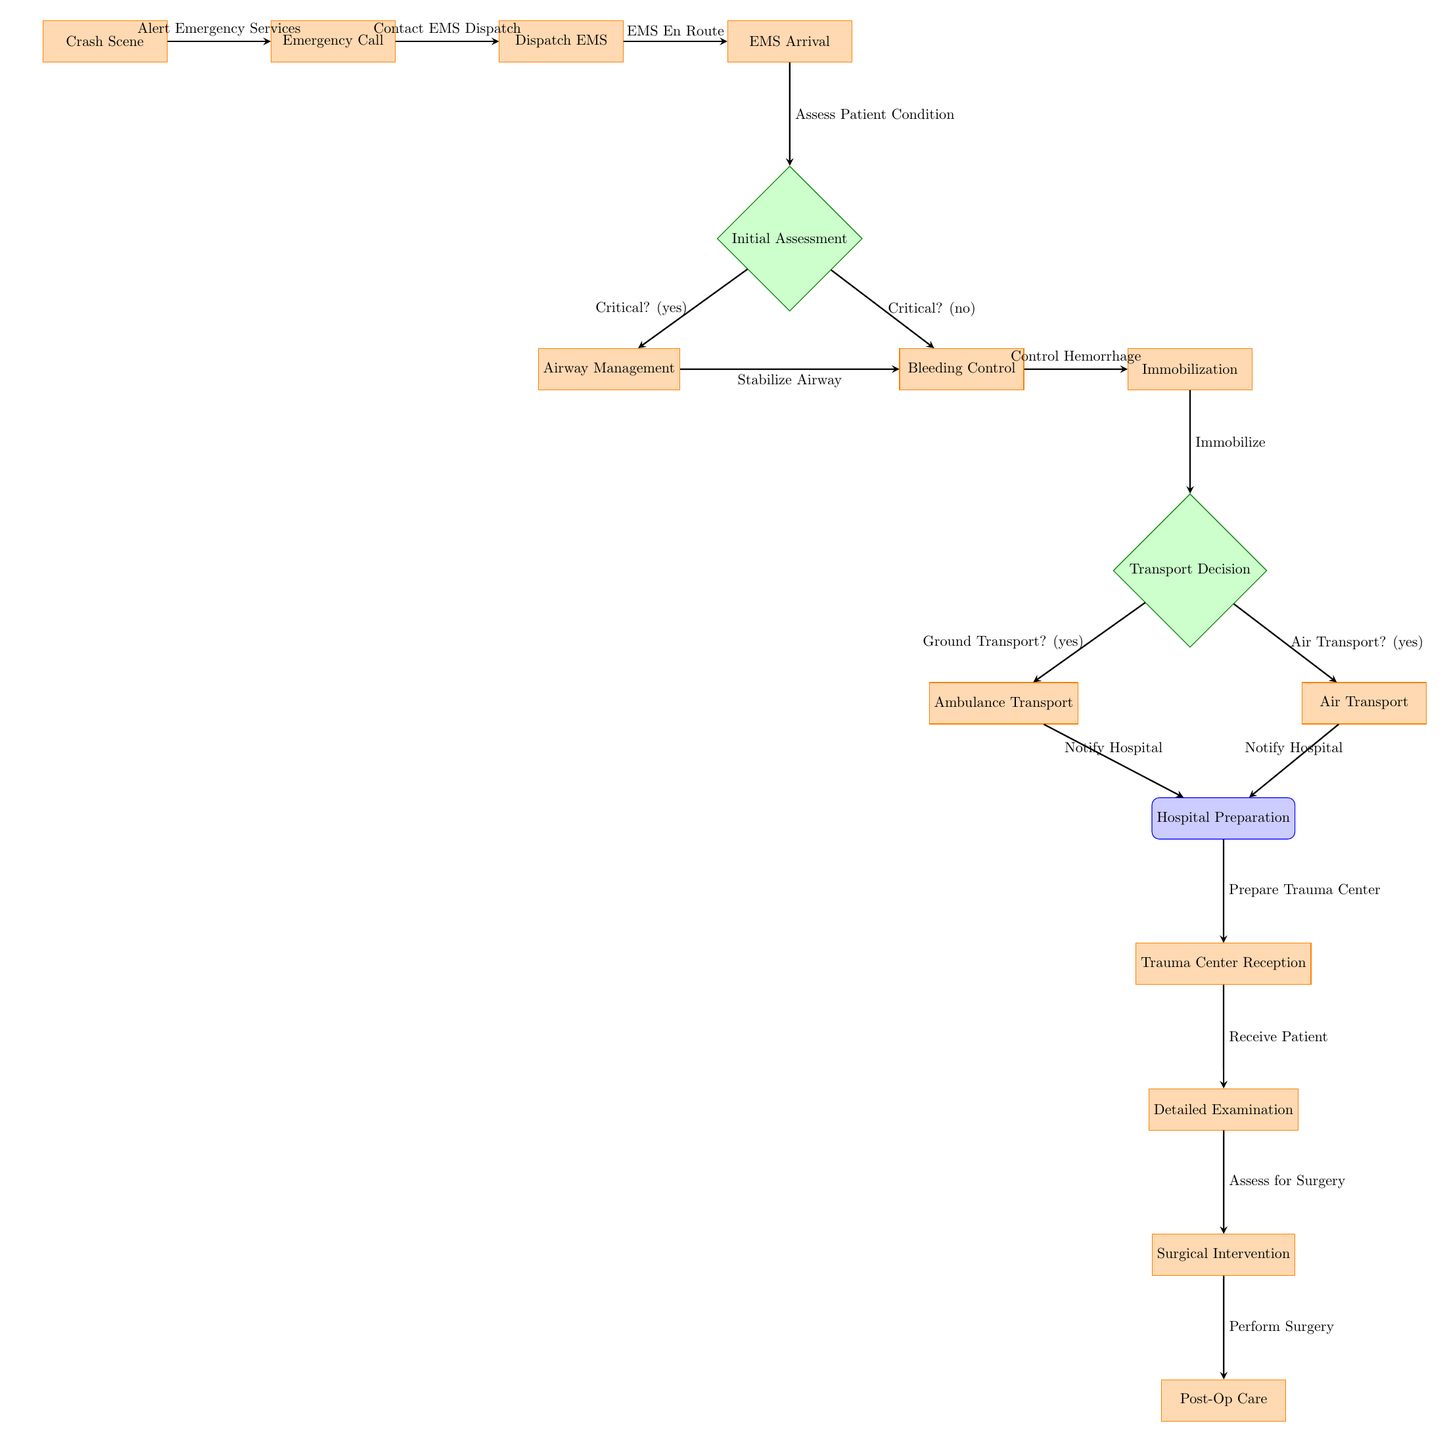What is the first process in the diagram? The first process listed in the diagram is "Crash Scene," which appears at the top as the starting point of the flowchart.
Answer: Crash Scene How many decision points are in the diagram? There are three decision points in the diagram, indicated by the diamond-shaped nodes, where important choices are made regarding patient urgency and transport methods.
Answer: 3 What process follows the "Airway Management" step? After "Airway Management," the next step is "Bleeding Control," which is the right branch from the "Initial Assessment" decision point.
Answer: Bleeding Control What happens if the "Transport Decision" is "Air Transport"? If the decision is "Air Transport," the next step is "Air Transport," where the EMS will utilize air transport to take the patient to the hospital. Following this, the process indicates "Notify Hospital."
Answer: Notify Hospital Which process comes after "Trauma Center Reception"? The next process after "Trauma Center Reception" is "Detailed Examination," where the patient will be assessed further before any surgical decisions.
Answer: Detailed Examination What is the relationship between "Immobilization" and "Transport Decision"? The "Immobilization" process feeds directly into the "Transport Decision" decision point, indicating that immobilization is achieved before deciding the mode of transport.
Answer: Direct connection What type of node is "Initial Assessment"? "Initial Assessment" is a decision node represented by a diamond shape, where a critical evaluation occurs to determine the urgency of the patient's condition.
Answer: Decision What must happen before "Surgical Intervention"? Before "Surgical Intervention," there must be a "Detailed Examination," which serves as a prerequisite to assess if surgery is necessary.
Answer: Detailed Examination 